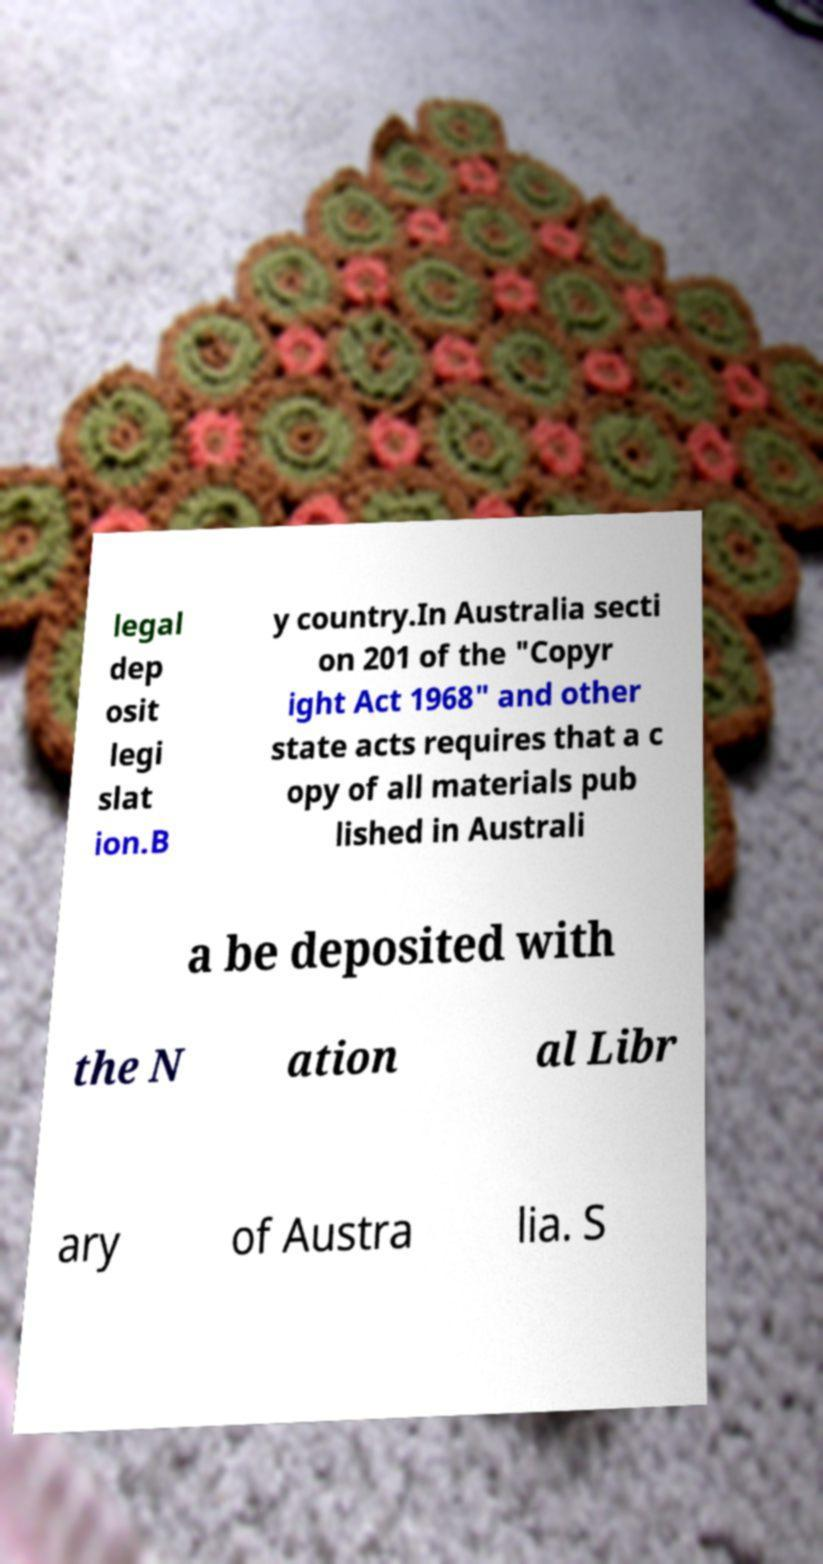Could you assist in decoding the text presented in this image and type it out clearly? legal dep osit legi slat ion.B y country.In Australia secti on 201 of the "Copyr ight Act 1968" and other state acts requires that a c opy of all materials pub lished in Australi a be deposited with the N ation al Libr ary of Austra lia. S 